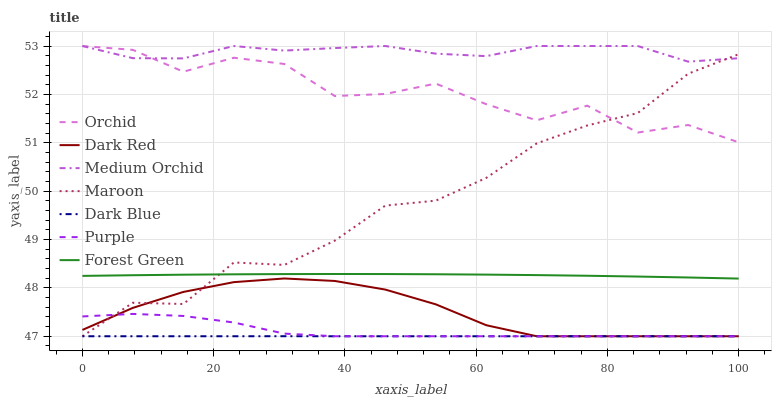Does Dark Blue have the minimum area under the curve?
Answer yes or no. Yes. Does Medium Orchid have the maximum area under the curve?
Answer yes or no. Yes. Does Dark Red have the minimum area under the curve?
Answer yes or no. No. Does Dark Red have the maximum area under the curve?
Answer yes or no. No. Is Dark Blue the smoothest?
Answer yes or no. Yes. Is Orchid the roughest?
Answer yes or no. Yes. Is Dark Red the smoothest?
Answer yes or no. No. Is Dark Red the roughest?
Answer yes or no. No. Does Medium Orchid have the lowest value?
Answer yes or no. No. Does Orchid have the highest value?
Answer yes or no. Yes. Does Dark Red have the highest value?
Answer yes or no. No. Is Dark Red less than Forest Green?
Answer yes or no. Yes. Is Forest Green greater than Dark Red?
Answer yes or no. Yes. Does Maroon intersect Orchid?
Answer yes or no. Yes. Is Maroon less than Orchid?
Answer yes or no. No. Is Maroon greater than Orchid?
Answer yes or no. No. Does Dark Red intersect Forest Green?
Answer yes or no. No. 